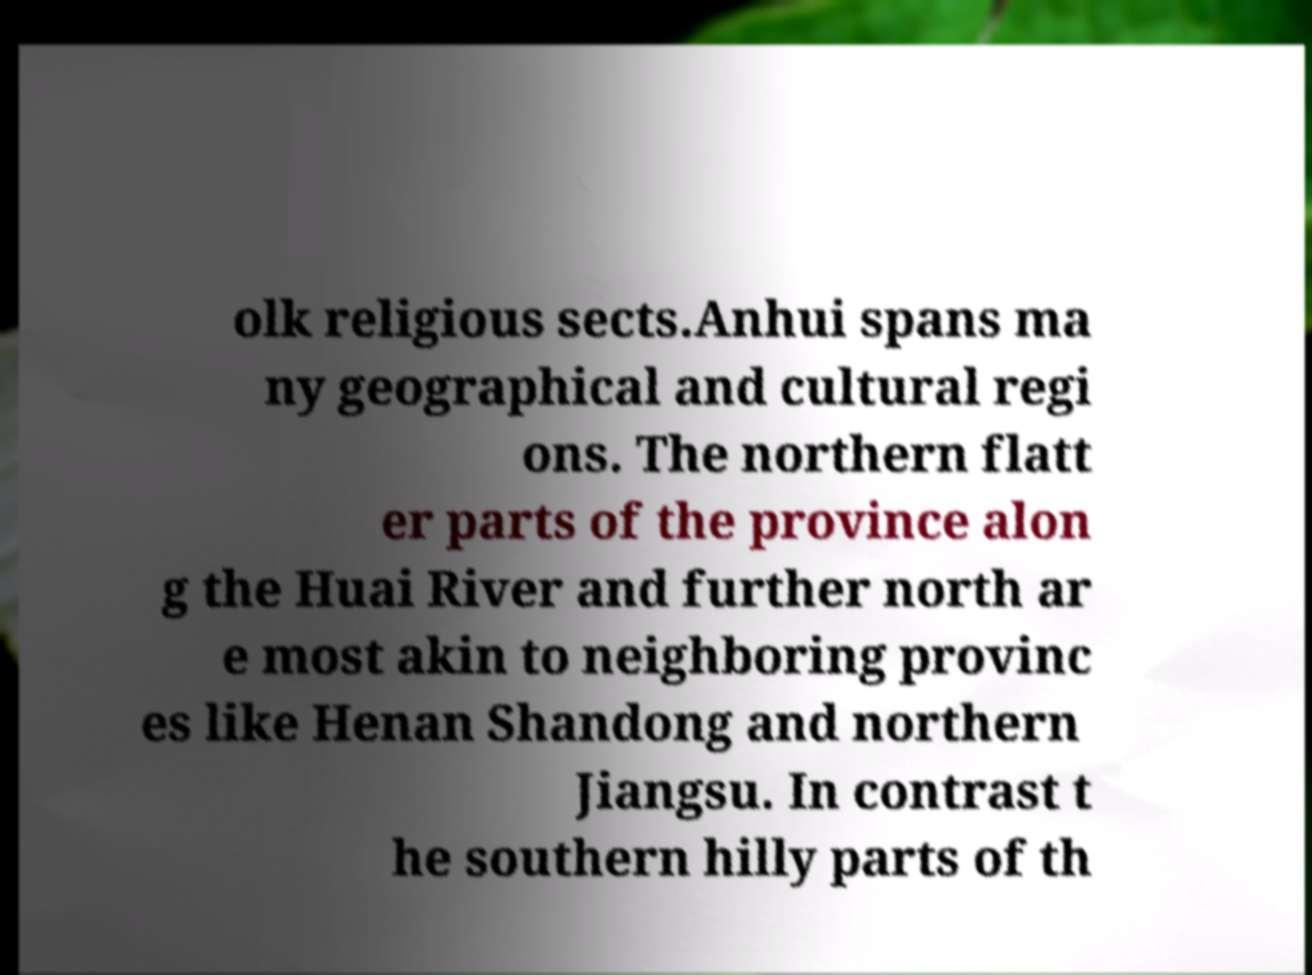Can you read and provide the text displayed in the image?This photo seems to have some interesting text. Can you extract and type it out for me? olk religious sects.Anhui spans ma ny geographical and cultural regi ons. The northern flatt er parts of the province alon g the Huai River and further north ar e most akin to neighboring provinc es like Henan Shandong and northern Jiangsu. In contrast t he southern hilly parts of th 